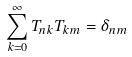Convert formula to latex. <formula><loc_0><loc_0><loc_500><loc_500>\sum _ { k = 0 } ^ { \infty } T _ { n k } T _ { k m } = \delta _ { n m }</formula> 